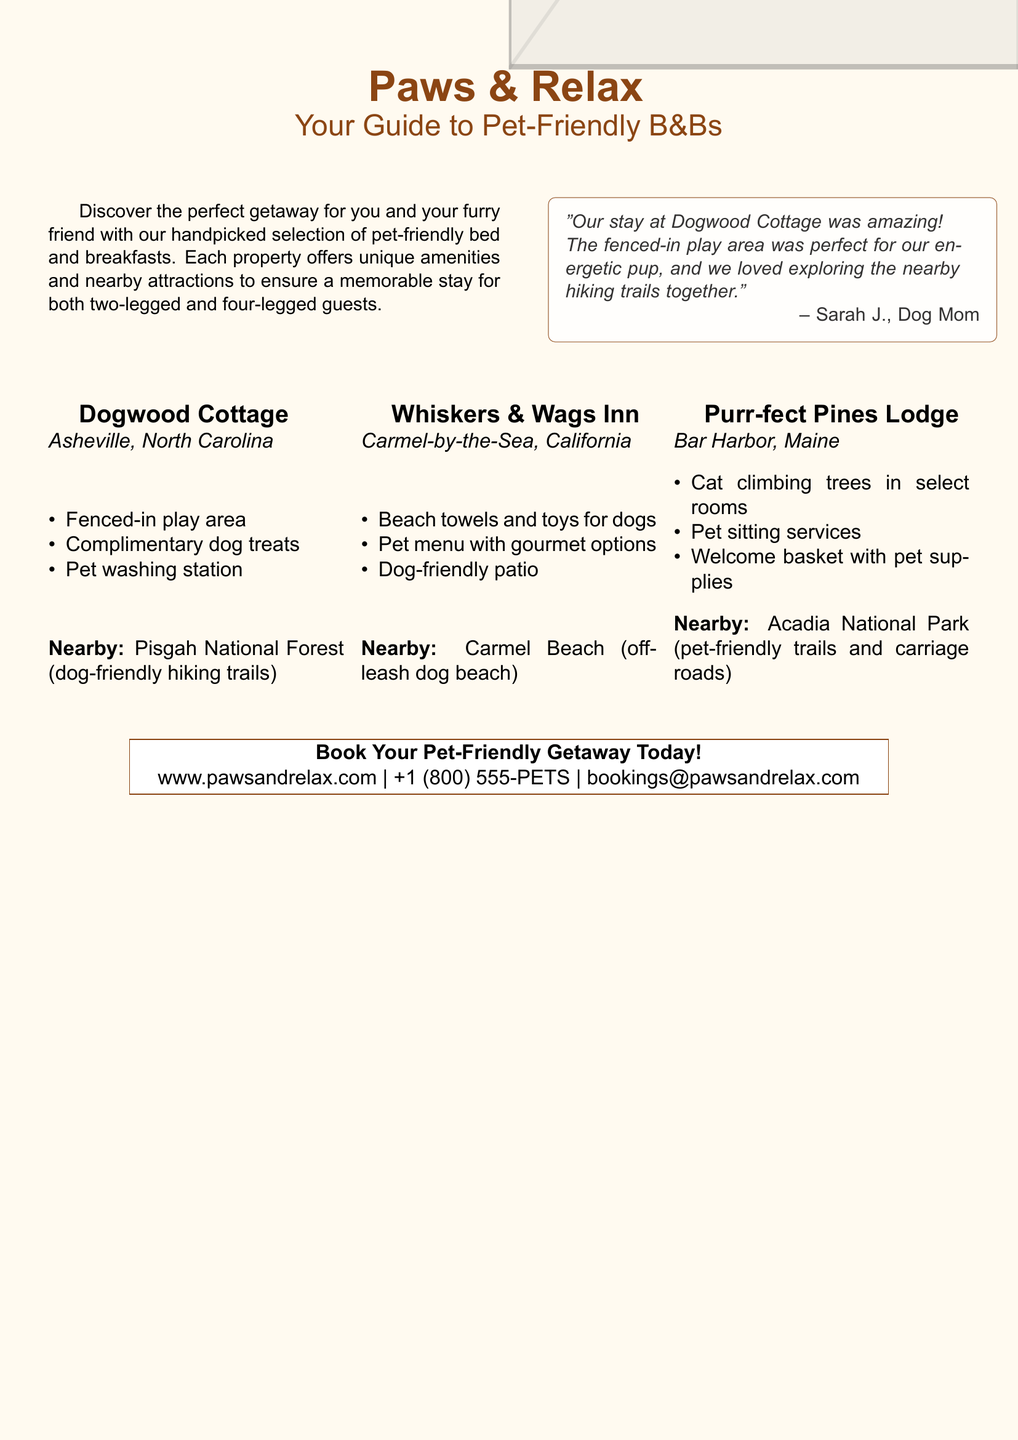What is the name of the catalog? The title of the catalog is prominently displayed at the top of the document.
Answer: Paws & Relax How many B&Bs are highlighted? The document lists three specific B&Bs with descriptions.
Answer: Three What amenity is offered at Dogwood Cottage? Each B&B features a unique set of amenities; Dogwood Cottage has a specific amenity mentioned.
Answer: Fenced-in play area Where is Whiskers & Wags Inn located? The location of each B&B is included in the descriptions.
Answer: Carmel-by-the-Sea, California What is provided in the welcome basket at Purr-fect Pines Lodge? The document details what is included in the welcome basket for pets.
Answer: Pet supplies Which nearby attraction is listed for Dogwood Cottage? Each B&B mentions a nearby pet-friendly attraction; this question focuses on Dogwood Cottage.
Answer: Pisgah National Forest What special feature does Purr-fect Pines Lodge offer for cats? The document states a unique amenity for cats at this B&B.
Answer: Cat climbing trees What is the contact information for bookings? The document includes explicit booking details in a specific section.
Answer: +1 (800) 555-PETS What type of menu does Whiskers & Wags Inn offer for pets? This question pertains to the pet-specific services offered at the B&B.
Answer: Gourmet options 